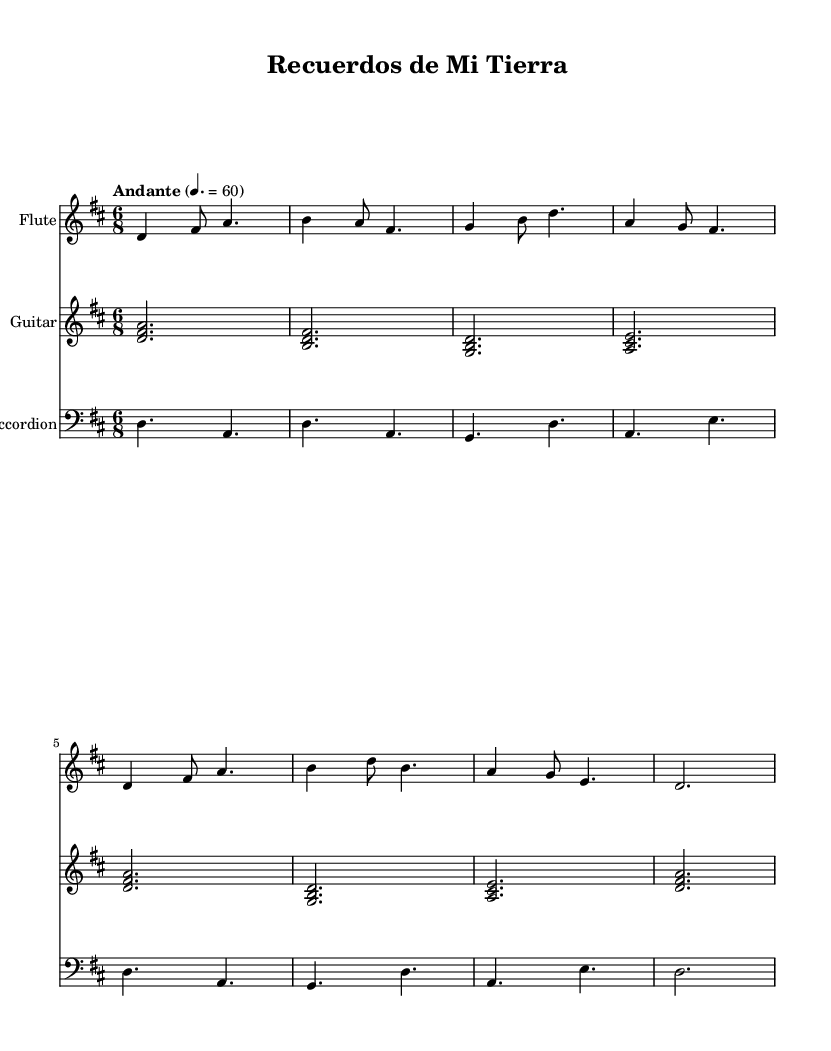What is the key signature of this music? The key signature shows two sharps, which indicates that the piece is in D major.
Answer: D major What is the time signature of this music? The time signature, displayed at the beginning of the staff, indicates that there are six beats in a measure, and each beat can be divided into an eighth note. This is characteristic of a compound meter.
Answer: 6/8 What is the tempo marking for this piece? The tempo marking indicates a moderate pace for the music, specifically defining that it should be played at 60 beats per minute.
Answer: Andante How many measures are there in the flute part? By counting the distinct groups of notes and rests in the flute staff, we find there are eight measures.
Answer: 8 Which instruments are featured in this composition? The score clearly labels three distinct staves for different instruments: Flute, Guitar, and Accordion, indicating they are all included in the piece.
Answer: Flute, Guitar, Accordion What type of music does this piece represent? Based on the title "Recuerdos de Mi Tierra" and the instrumentation involved, this piece draws on traditional Latin American folk music, reflecting themes of nostalgia for rural life.
Answer: Traditional Latin American folk music How many notes are played in the first measure of the flute part? In the first measure of the flute section, there are four notes played (D, F#, A, and B), which makes it straightforward to count them.
Answer: 4 